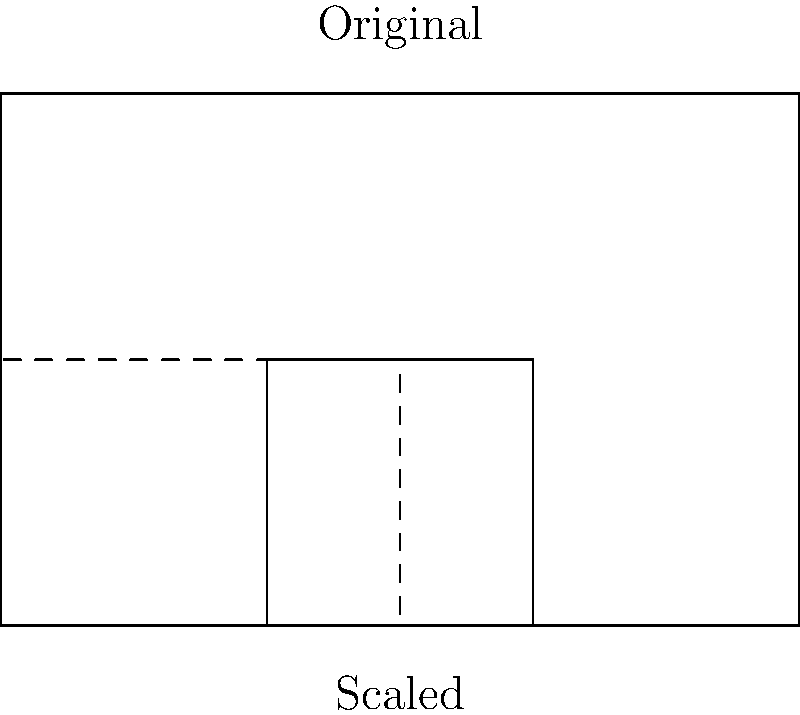As you prepare for your upcoming concert, you need to scale down the seating chart of the venue to accommodate social distancing measures. The original rectangular seating area measures 60 feet by 40 feet. If you apply a scale factor of 0.5 to create a smaller seating arrangement while maintaining the same shape, what will be the dimensions of the new seating area? To solve this problem, we'll follow these steps:

1. Identify the original dimensions:
   Length = 60 feet
   Width = 40 feet

2. Understand the scale factor:
   Scale factor = 0.5

3. Apply the scale factor to both dimensions:
   
   For the length:
   $$\text{New length} = \text{Original length} \times \text{Scale factor}$$
   $$\text{New length} = 60 \text{ feet} \times 0.5 = 30 \text{ feet}$$

   For the width:
   $$\text{New width} = \text{Original width} \times \text{Scale factor}$$
   $$\text{New width} = 40 \text{ feet} \times 0.5 = 20 \text{ feet}$$

4. The new dimensions of the scaled seating area are 30 feet by 20 feet.

This scaling ensures that the shape of the seating area remains the same while reducing its size by half, which can help in implementing social distancing measures for your concert.
Answer: 30 feet by 20 feet 